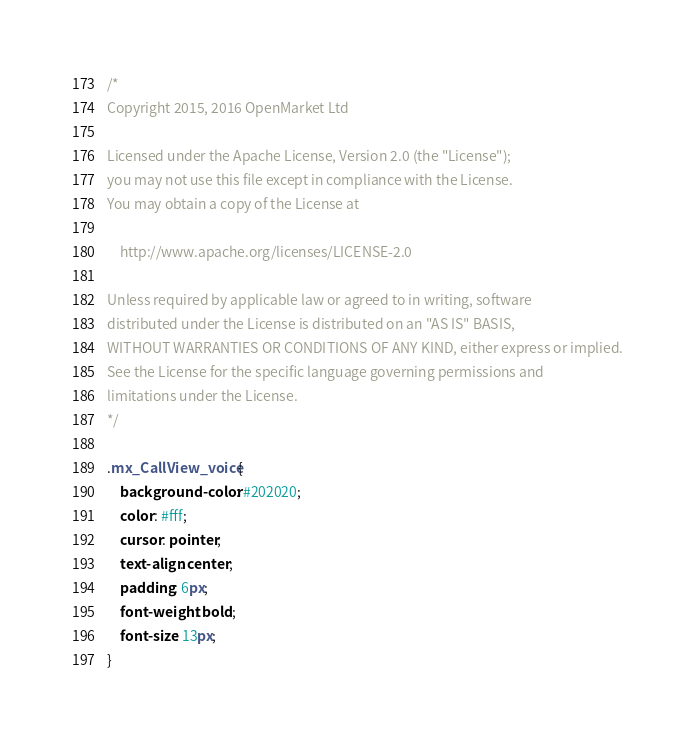<code> <loc_0><loc_0><loc_500><loc_500><_CSS_>/*
Copyright 2015, 2016 OpenMarket Ltd

Licensed under the Apache License, Version 2.0 (the "License");
you may not use this file except in compliance with the License.
You may obtain a copy of the License at

    http://www.apache.org/licenses/LICENSE-2.0

Unless required by applicable law or agreed to in writing, software
distributed under the License is distributed on an "AS IS" BASIS,
WITHOUT WARRANTIES OR CONDITIONS OF ANY KIND, either express or implied.
See the License for the specific language governing permissions and
limitations under the License.
*/

.mx_CallView_voice {
    background-color: #202020;
    color: #fff;
    cursor: pointer;
    text-align: center;
    padding: 6px;
    font-weight: bold;
    font-size: 13px;
}</code> 